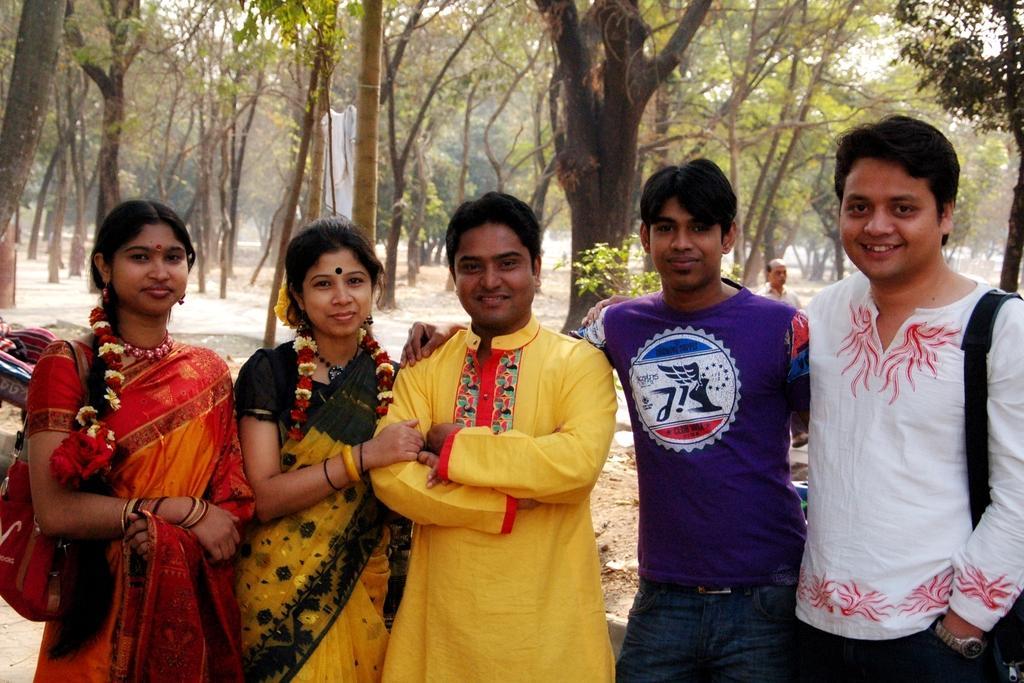Could you give a brief overview of what you see in this image? In this image I can see 3 men and 2 women are standing. These women are wearing sarees. In the background I can see trees, a person and the sky. 